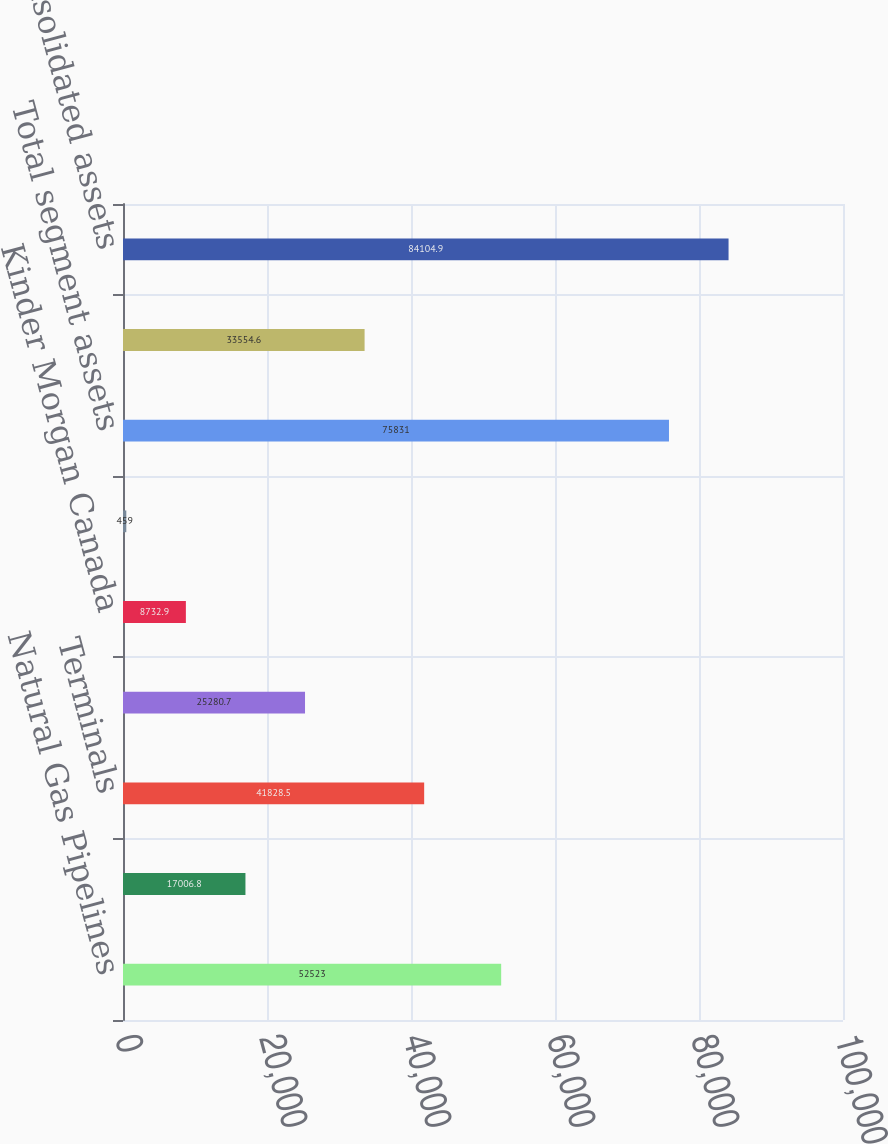Convert chart. <chart><loc_0><loc_0><loc_500><loc_500><bar_chart><fcel>Natural Gas Pipelines<fcel>CO2<fcel>Terminals<fcel>Products Pipelines<fcel>Kinder Morgan Canada<fcel>Other<fcel>Total segment assets<fcel>Corporate assets(l)<fcel>Total consolidated assets<nl><fcel>52523<fcel>17006.8<fcel>41828.5<fcel>25280.7<fcel>8732.9<fcel>459<fcel>75831<fcel>33554.6<fcel>84104.9<nl></chart> 